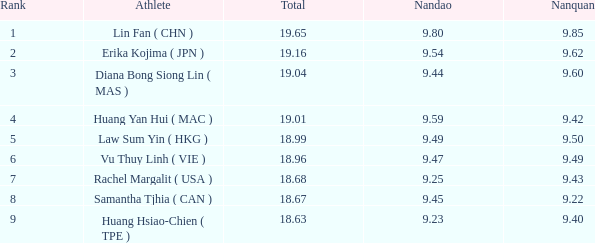Which Nanquan has a Nandao smaller than 9.44, and a Rank smaller than 9, and a Total larger than 18.68? None. 